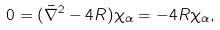<formula> <loc_0><loc_0><loc_500><loc_500>0 = ( \bar { \nabla } ^ { 2 } - 4 R ) \chi _ { \alpha } = - 4 R \chi _ { \alpha } ,</formula> 